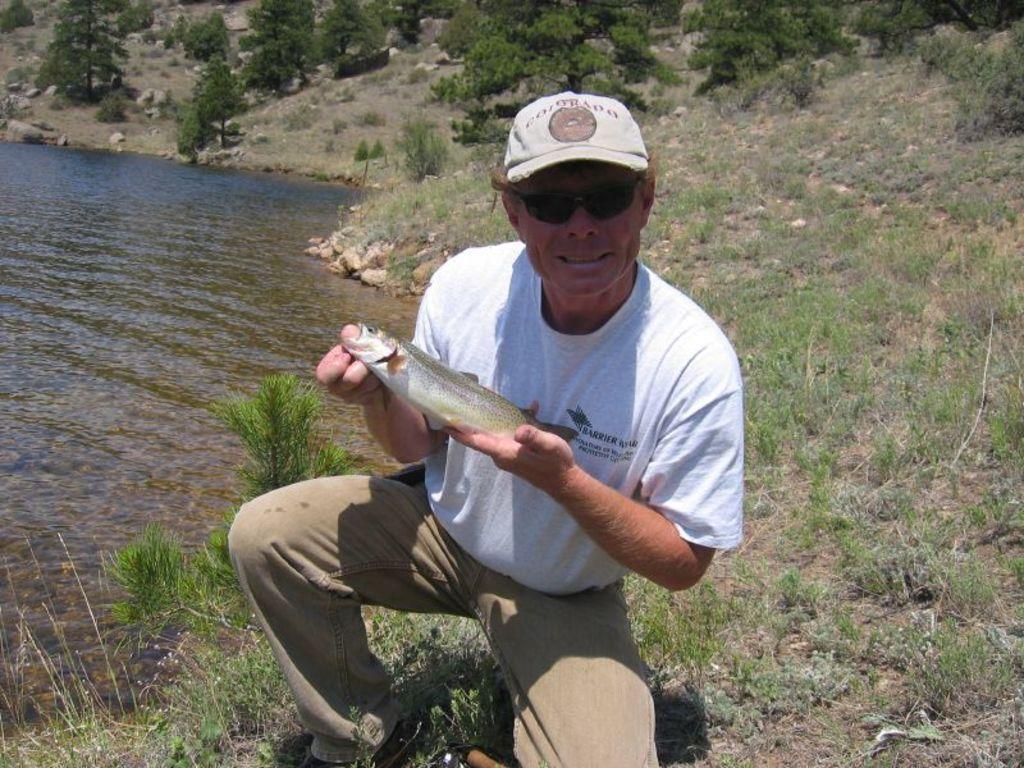Can you describe this image briefly? In this image I can see a man is holding a fish in hands. The man is wearing a cap, shades, a white color t-shirt and a pant. In the background I can see the grass, water and trees. 